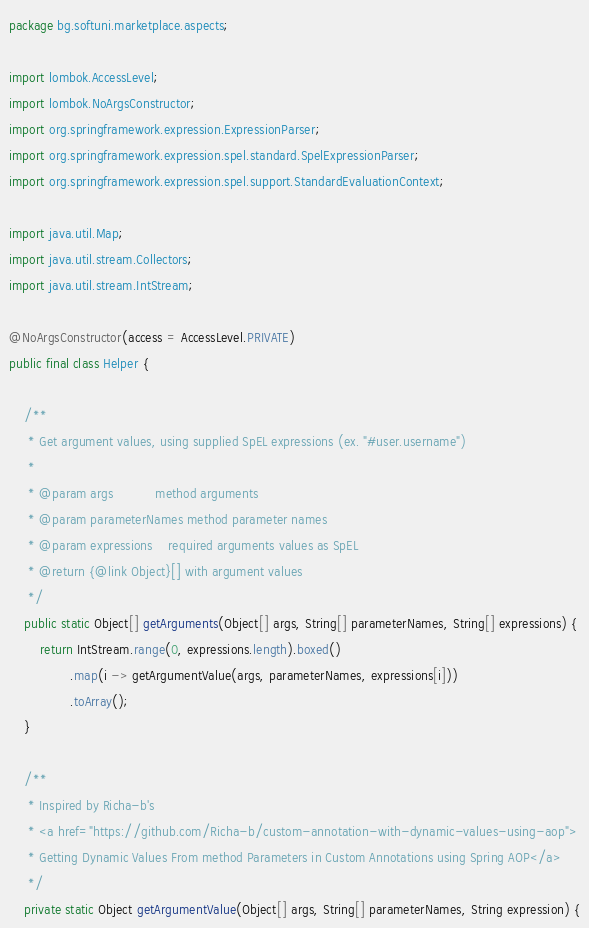Convert code to text. <code><loc_0><loc_0><loc_500><loc_500><_Java_>package bg.softuni.marketplace.aspects;

import lombok.AccessLevel;
import lombok.NoArgsConstructor;
import org.springframework.expression.ExpressionParser;
import org.springframework.expression.spel.standard.SpelExpressionParser;
import org.springframework.expression.spel.support.StandardEvaluationContext;

import java.util.Map;
import java.util.stream.Collectors;
import java.util.stream.IntStream;

@NoArgsConstructor(access = AccessLevel.PRIVATE)
public final class Helper {

    /**
     * Get argument values, using supplied SpEL expressions (ex. "#user.username")
     *
     * @param args           method arguments
     * @param parameterNames method parameter names
     * @param expressions    required arguments values as SpEL
     * @return {@link Object}[] with argument values
     */
    public static Object[] getArguments(Object[] args, String[] parameterNames, String[] expressions) {
        return IntStream.range(0, expressions.length).boxed()
                .map(i -> getArgumentValue(args, parameterNames, expressions[i]))
                .toArray();
    }

    /**
     * Inspired by Richa-b's
     * <a href="https://github.com/Richa-b/custom-annotation-with-dynamic-values-using-aop">
     * Getting Dynamic Values From method Parameters in Custom Annotations using Spring AOP</a>
     */
    private static Object getArgumentValue(Object[] args, String[] parameterNames, String expression) {</code> 